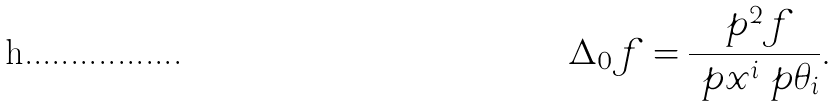Convert formula to latex. <formula><loc_0><loc_0><loc_500><loc_500>\Delta _ { 0 } f = \frac { \ p ^ { 2 } f } { \ p x ^ { i } \ p \theta _ { i } } .</formula> 